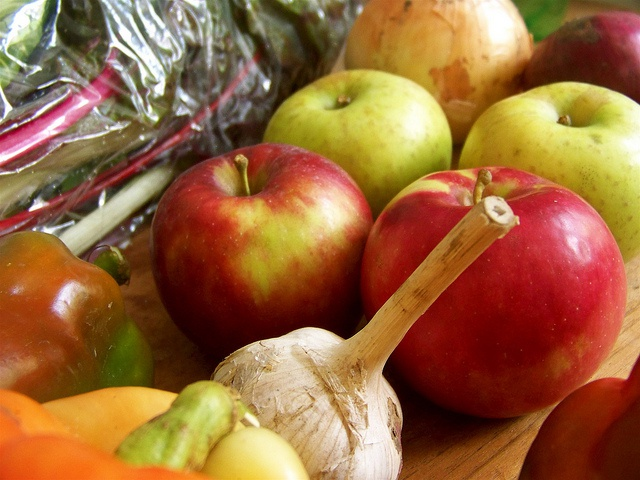Describe the objects in this image and their specific colors. I can see apple in beige, maroon, salmon, and brown tones, apple in beige, maroon, black, and brown tones, apple in beige, olive, and khaki tones, apple in beige, olive, and khaki tones, and apple in beige, maroon, and brown tones in this image. 